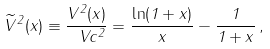<formula> <loc_0><loc_0><loc_500><loc_500>\widetilde { V } ^ { 2 } ( x ) \equiv \frac { V ^ { 2 } ( x ) } { \ V c ^ { 2 } } = \frac { \ln ( 1 + x ) } { x } - \frac { 1 } { 1 + x } \, ,</formula> 